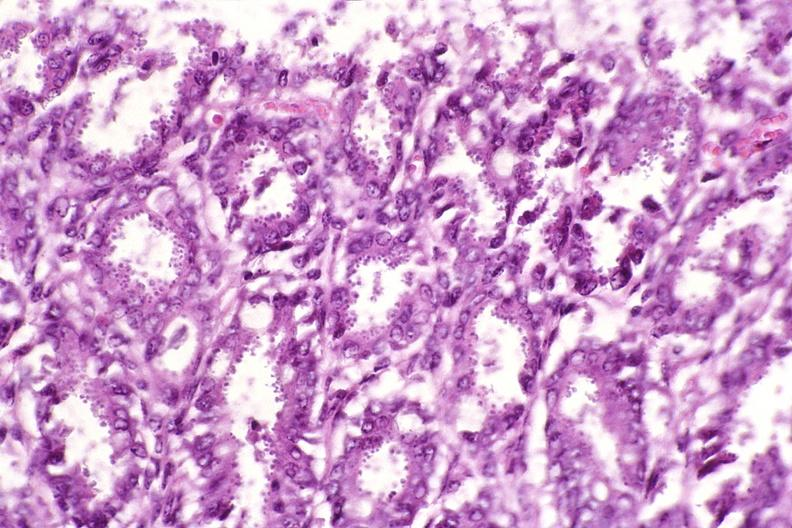does granulomata slide show colon, cryptosporidia?
Answer the question using a single word or phrase. No 